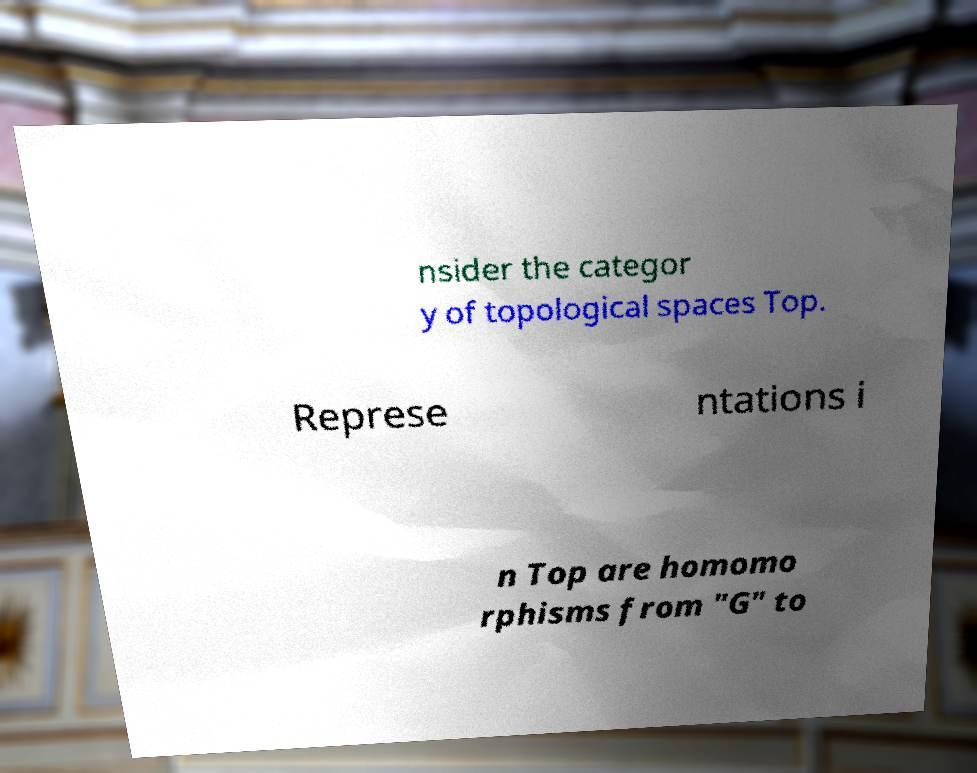Please read and relay the text visible in this image. What does it say? nsider the categor y of topological spaces Top. Represe ntations i n Top are homomo rphisms from "G" to 